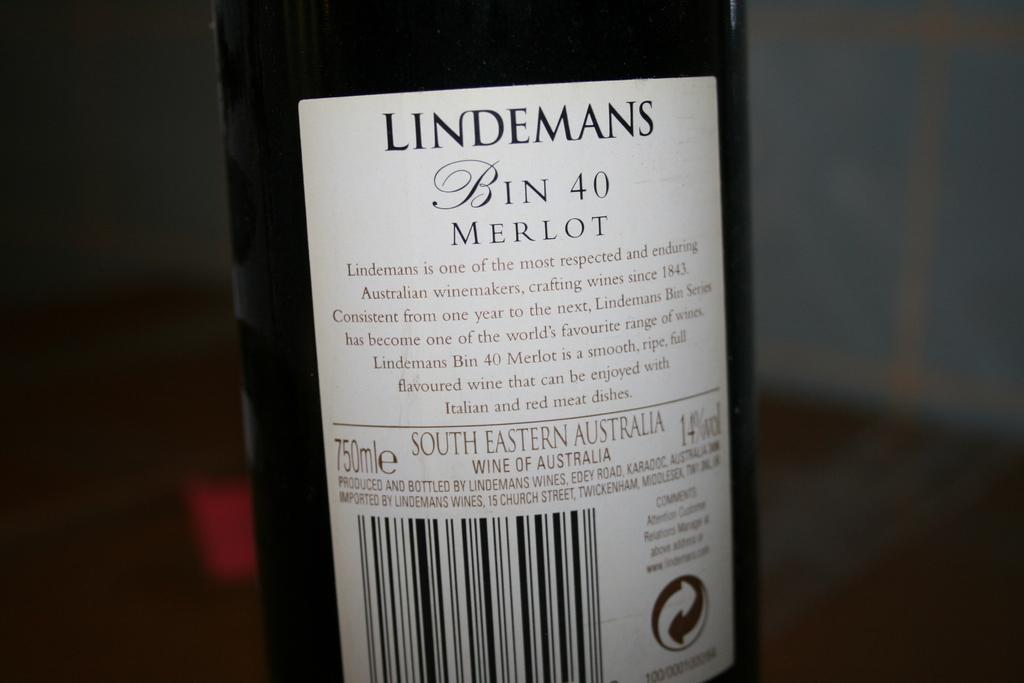<image>
Create a compact narrative representing the image presented. A close up of the rear label of a bottle of Lindemans Merlot. 